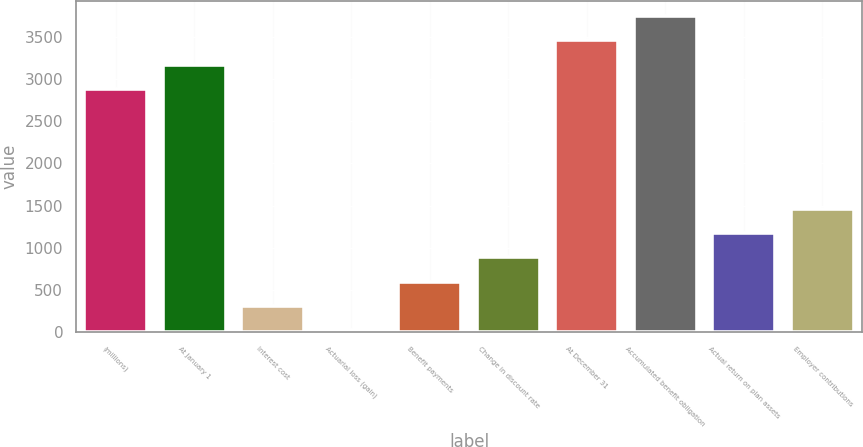Convert chart. <chart><loc_0><loc_0><loc_500><loc_500><bar_chart><fcel>(millions)<fcel>At January 1<fcel>Interest cost<fcel>Actuarial loss (gain)<fcel>Benefit payments<fcel>Change in discount rate<fcel>At December 31<fcel>Accumulated benefit obligation<fcel>Actual return on plan assets<fcel>Employer contributions<nl><fcel>2884<fcel>3169.5<fcel>314.5<fcel>29<fcel>600<fcel>885.5<fcel>3455<fcel>3740.5<fcel>1171<fcel>1456.5<nl></chart> 